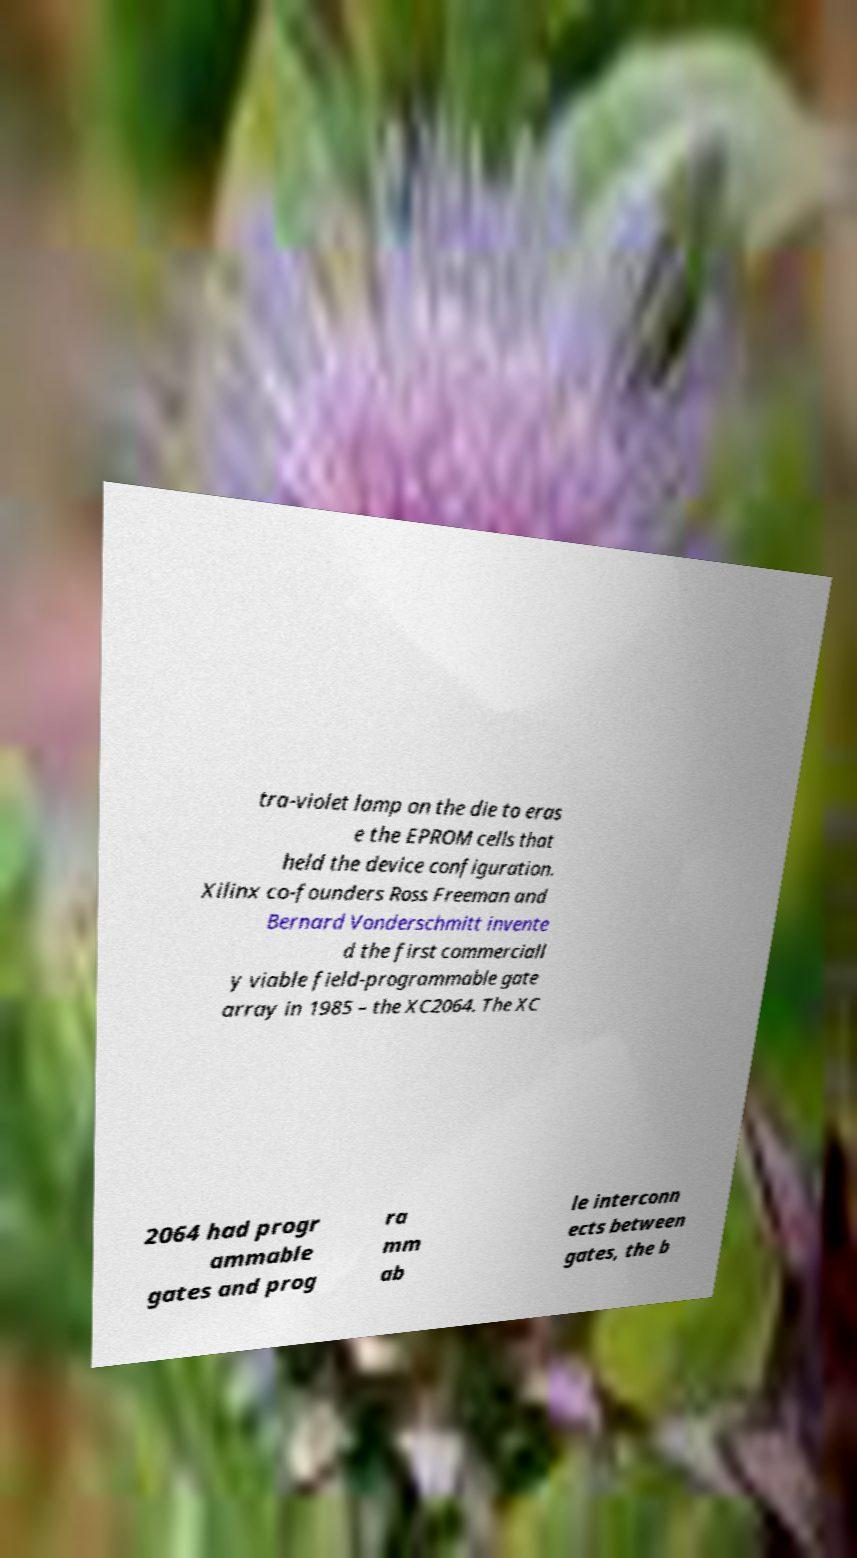Please read and relay the text visible in this image. What does it say? tra-violet lamp on the die to eras e the EPROM cells that held the device configuration. Xilinx co-founders Ross Freeman and Bernard Vonderschmitt invente d the first commerciall y viable field-programmable gate array in 1985 – the XC2064. The XC 2064 had progr ammable gates and prog ra mm ab le interconn ects between gates, the b 